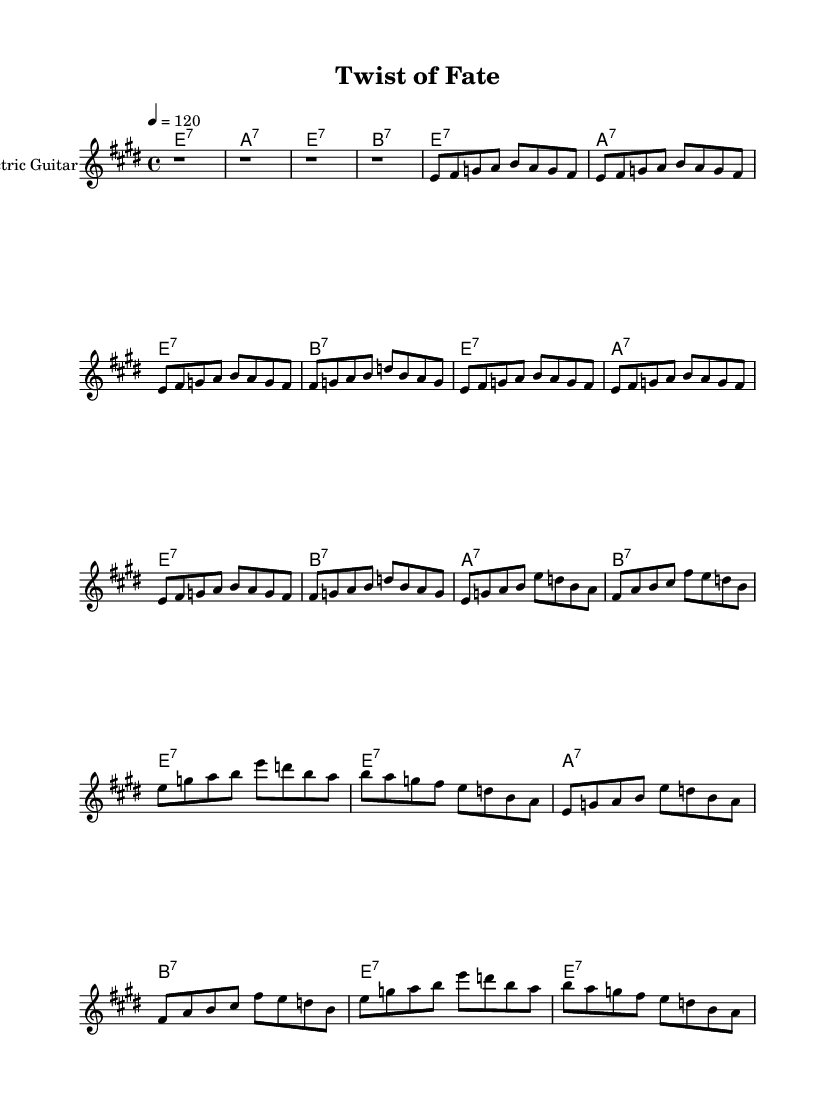What is the key signature of this music? The key signature is E major, which has four sharps (F#, C#, G#, and D#). This can be deduced from the indication of "e" in the global block.
Answer: E major What is the time signature of the piece? The time signature is 4/4, as indicated in the global block of the code. This means there are four beats in each measure.
Answer: 4/4 What is the tempo marking of this piece? The tempo marking is 120 beats per minute, as indicated by "4 = 120" in the global settings. This specifies the speed of the music.
Answer: 120 How many bars are in the intro section? There are 4 bars in the intro section, as denoted by the four measures of rests (r1) at the beginning of the electric guitar part.
Answer: 4 What is the chord progression in the verse? The chord progression in the verse is E7, A7, E7, B7 repeated twice, which is derived from the chord names provided under the verse section in the chord mode.
Answer: E7, A7, E7, B7 What is the total number of bars in the chorus? The total number of bars in the chorus is 8, as the chorus section consists of 8 measures of music outlined in the chord mode and the electric guitar part.
Answer: 8 What defines this music as Electric Blues? The energetic riffs, use of electric guitar, and the specific chord progression (based on E7, A7, etc.) coupled with a driving beat characterize it as Electric Blues, which reflects the genre's traits.
Answer: Electric Blues 